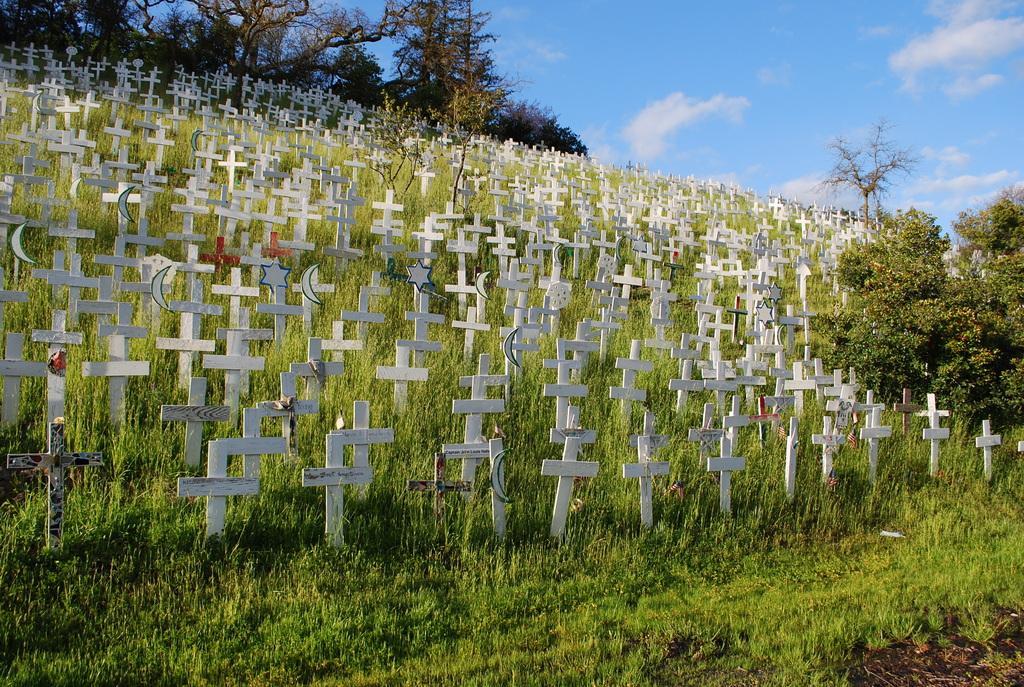Please provide a concise description of this image. In the foreground of this image, there are many cross symbols placed on the ground. In the background there are trees, the sky and the cloud. 